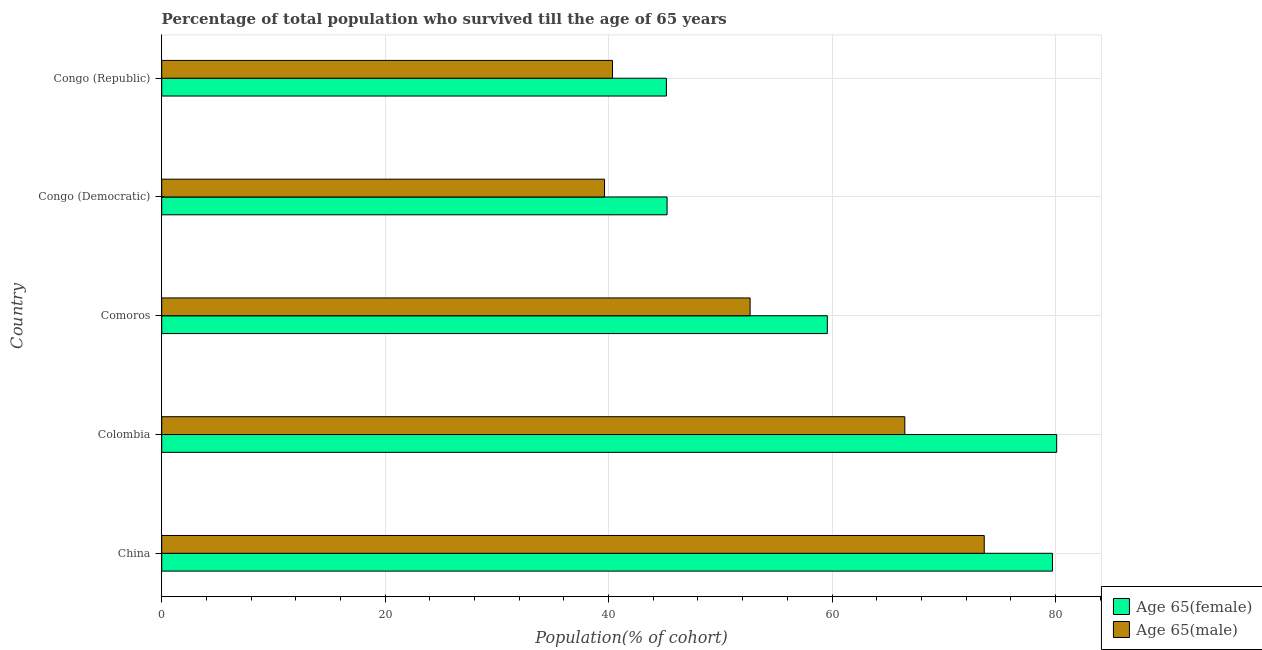How many different coloured bars are there?
Provide a short and direct response. 2. Are the number of bars per tick equal to the number of legend labels?
Give a very brief answer. Yes. How many bars are there on the 5th tick from the top?
Keep it short and to the point. 2. What is the label of the 3rd group of bars from the top?
Give a very brief answer. Comoros. In how many cases, is the number of bars for a given country not equal to the number of legend labels?
Your answer should be very brief. 0. What is the percentage of male population who survived till age of 65 in China?
Offer a terse response. 73.63. Across all countries, what is the maximum percentage of female population who survived till age of 65?
Offer a terse response. 80.11. Across all countries, what is the minimum percentage of male population who survived till age of 65?
Give a very brief answer. 39.64. In which country was the percentage of male population who survived till age of 65 minimum?
Keep it short and to the point. Congo (Democratic). What is the total percentage of male population who survived till age of 65 in the graph?
Offer a terse response. 272.8. What is the difference between the percentage of female population who survived till age of 65 in Colombia and that in Congo (Republic)?
Make the answer very short. 34.94. What is the difference between the percentage of male population who survived till age of 65 in Congo (Democratic) and the percentage of female population who survived till age of 65 in Comoros?
Offer a terse response. -19.94. What is the average percentage of female population who survived till age of 65 per country?
Provide a short and direct response. 61.97. What is the difference between the percentage of female population who survived till age of 65 and percentage of male population who survived till age of 65 in Colombia?
Provide a succinct answer. 13.59. In how many countries, is the percentage of female population who survived till age of 65 greater than 52 %?
Keep it short and to the point. 3. What is the ratio of the percentage of female population who survived till age of 65 in China to that in Congo (Republic)?
Provide a succinct answer. 1.76. What is the difference between the highest and the second highest percentage of male population who survived till age of 65?
Keep it short and to the point. 7.11. What is the difference between the highest and the lowest percentage of male population who survived till age of 65?
Provide a short and direct response. 33.99. What does the 1st bar from the top in Congo (Democratic) represents?
Give a very brief answer. Age 65(male). What does the 2nd bar from the bottom in Congo (Republic) represents?
Offer a very short reply. Age 65(male). How many bars are there?
Keep it short and to the point. 10. Are all the bars in the graph horizontal?
Offer a very short reply. Yes. Does the graph contain any zero values?
Give a very brief answer. No. Does the graph contain grids?
Give a very brief answer. Yes. Where does the legend appear in the graph?
Your answer should be compact. Bottom right. What is the title of the graph?
Give a very brief answer. Percentage of total population who survived till the age of 65 years. What is the label or title of the X-axis?
Make the answer very short. Population(% of cohort). What is the label or title of the Y-axis?
Offer a very short reply. Country. What is the Population(% of cohort) of Age 65(female) in China?
Give a very brief answer. 79.73. What is the Population(% of cohort) of Age 65(male) in China?
Your answer should be compact. 73.63. What is the Population(% of cohort) of Age 65(female) in Colombia?
Provide a short and direct response. 80.11. What is the Population(% of cohort) of Age 65(male) in Colombia?
Offer a terse response. 66.52. What is the Population(% of cohort) of Age 65(female) in Comoros?
Provide a succinct answer. 59.58. What is the Population(% of cohort) in Age 65(male) in Comoros?
Ensure brevity in your answer.  52.67. What is the Population(% of cohort) of Age 65(female) in Congo (Democratic)?
Offer a terse response. 45.24. What is the Population(% of cohort) of Age 65(male) in Congo (Democratic)?
Your response must be concise. 39.64. What is the Population(% of cohort) of Age 65(female) in Congo (Republic)?
Provide a short and direct response. 45.17. What is the Population(% of cohort) in Age 65(male) in Congo (Republic)?
Provide a short and direct response. 40.35. Across all countries, what is the maximum Population(% of cohort) of Age 65(female)?
Your answer should be very brief. 80.11. Across all countries, what is the maximum Population(% of cohort) of Age 65(male)?
Your answer should be very brief. 73.63. Across all countries, what is the minimum Population(% of cohort) in Age 65(female)?
Your response must be concise. 45.17. Across all countries, what is the minimum Population(% of cohort) in Age 65(male)?
Ensure brevity in your answer.  39.64. What is the total Population(% of cohort) of Age 65(female) in the graph?
Make the answer very short. 309.84. What is the total Population(% of cohort) of Age 65(male) in the graph?
Provide a short and direct response. 272.8. What is the difference between the Population(% of cohort) of Age 65(female) in China and that in Colombia?
Offer a terse response. -0.38. What is the difference between the Population(% of cohort) of Age 65(male) in China and that in Colombia?
Keep it short and to the point. 7.11. What is the difference between the Population(% of cohort) of Age 65(female) in China and that in Comoros?
Your answer should be very brief. 20.15. What is the difference between the Population(% of cohort) in Age 65(male) in China and that in Comoros?
Your answer should be compact. 20.96. What is the difference between the Population(% of cohort) in Age 65(female) in China and that in Congo (Democratic)?
Give a very brief answer. 34.5. What is the difference between the Population(% of cohort) in Age 65(male) in China and that in Congo (Democratic)?
Your response must be concise. 33.99. What is the difference between the Population(% of cohort) of Age 65(female) in China and that in Congo (Republic)?
Keep it short and to the point. 34.56. What is the difference between the Population(% of cohort) in Age 65(male) in China and that in Congo (Republic)?
Give a very brief answer. 33.27. What is the difference between the Population(% of cohort) in Age 65(female) in Colombia and that in Comoros?
Keep it short and to the point. 20.53. What is the difference between the Population(% of cohort) in Age 65(male) in Colombia and that in Comoros?
Keep it short and to the point. 13.85. What is the difference between the Population(% of cohort) of Age 65(female) in Colombia and that in Congo (Democratic)?
Your response must be concise. 34.87. What is the difference between the Population(% of cohort) in Age 65(male) in Colombia and that in Congo (Democratic)?
Your response must be concise. 26.88. What is the difference between the Population(% of cohort) in Age 65(female) in Colombia and that in Congo (Republic)?
Give a very brief answer. 34.94. What is the difference between the Population(% of cohort) of Age 65(male) in Colombia and that in Congo (Republic)?
Offer a very short reply. 26.16. What is the difference between the Population(% of cohort) in Age 65(female) in Comoros and that in Congo (Democratic)?
Keep it short and to the point. 14.34. What is the difference between the Population(% of cohort) in Age 65(male) in Comoros and that in Congo (Democratic)?
Give a very brief answer. 13.03. What is the difference between the Population(% of cohort) of Age 65(female) in Comoros and that in Congo (Republic)?
Provide a succinct answer. 14.41. What is the difference between the Population(% of cohort) of Age 65(male) in Comoros and that in Congo (Republic)?
Your answer should be compact. 12.32. What is the difference between the Population(% of cohort) of Age 65(female) in Congo (Democratic) and that in Congo (Republic)?
Ensure brevity in your answer.  0.06. What is the difference between the Population(% of cohort) of Age 65(male) in Congo (Democratic) and that in Congo (Republic)?
Provide a succinct answer. -0.71. What is the difference between the Population(% of cohort) in Age 65(female) in China and the Population(% of cohort) in Age 65(male) in Colombia?
Make the answer very short. 13.22. What is the difference between the Population(% of cohort) in Age 65(female) in China and the Population(% of cohort) in Age 65(male) in Comoros?
Provide a short and direct response. 27.06. What is the difference between the Population(% of cohort) in Age 65(female) in China and the Population(% of cohort) in Age 65(male) in Congo (Democratic)?
Your answer should be very brief. 40.1. What is the difference between the Population(% of cohort) of Age 65(female) in China and the Population(% of cohort) of Age 65(male) in Congo (Republic)?
Offer a terse response. 39.38. What is the difference between the Population(% of cohort) in Age 65(female) in Colombia and the Population(% of cohort) in Age 65(male) in Comoros?
Provide a short and direct response. 27.44. What is the difference between the Population(% of cohort) of Age 65(female) in Colombia and the Population(% of cohort) of Age 65(male) in Congo (Democratic)?
Keep it short and to the point. 40.47. What is the difference between the Population(% of cohort) of Age 65(female) in Colombia and the Population(% of cohort) of Age 65(male) in Congo (Republic)?
Make the answer very short. 39.76. What is the difference between the Population(% of cohort) of Age 65(female) in Comoros and the Population(% of cohort) of Age 65(male) in Congo (Democratic)?
Your answer should be compact. 19.94. What is the difference between the Population(% of cohort) in Age 65(female) in Comoros and the Population(% of cohort) in Age 65(male) in Congo (Republic)?
Provide a succinct answer. 19.23. What is the difference between the Population(% of cohort) of Age 65(female) in Congo (Democratic) and the Population(% of cohort) of Age 65(male) in Congo (Republic)?
Offer a very short reply. 4.89. What is the average Population(% of cohort) in Age 65(female) per country?
Offer a terse response. 61.97. What is the average Population(% of cohort) in Age 65(male) per country?
Keep it short and to the point. 54.56. What is the difference between the Population(% of cohort) of Age 65(female) and Population(% of cohort) of Age 65(male) in China?
Your response must be concise. 6.11. What is the difference between the Population(% of cohort) in Age 65(female) and Population(% of cohort) in Age 65(male) in Colombia?
Give a very brief answer. 13.59. What is the difference between the Population(% of cohort) of Age 65(female) and Population(% of cohort) of Age 65(male) in Comoros?
Your answer should be very brief. 6.91. What is the difference between the Population(% of cohort) of Age 65(female) and Population(% of cohort) of Age 65(male) in Congo (Democratic)?
Give a very brief answer. 5.6. What is the difference between the Population(% of cohort) of Age 65(female) and Population(% of cohort) of Age 65(male) in Congo (Republic)?
Give a very brief answer. 4.82. What is the ratio of the Population(% of cohort) of Age 65(female) in China to that in Colombia?
Your answer should be compact. 1. What is the ratio of the Population(% of cohort) in Age 65(male) in China to that in Colombia?
Your response must be concise. 1.11. What is the ratio of the Population(% of cohort) of Age 65(female) in China to that in Comoros?
Your answer should be compact. 1.34. What is the ratio of the Population(% of cohort) of Age 65(male) in China to that in Comoros?
Your response must be concise. 1.4. What is the ratio of the Population(% of cohort) of Age 65(female) in China to that in Congo (Democratic)?
Offer a very short reply. 1.76. What is the ratio of the Population(% of cohort) of Age 65(male) in China to that in Congo (Democratic)?
Offer a very short reply. 1.86. What is the ratio of the Population(% of cohort) of Age 65(female) in China to that in Congo (Republic)?
Provide a short and direct response. 1.76. What is the ratio of the Population(% of cohort) of Age 65(male) in China to that in Congo (Republic)?
Your response must be concise. 1.82. What is the ratio of the Population(% of cohort) of Age 65(female) in Colombia to that in Comoros?
Provide a short and direct response. 1.34. What is the ratio of the Population(% of cohort) of Age 65(male) in Colombia to that in Comoros?
Offer a terse response. 1.26. What is the ratio of the Population(% of cohort) in Age 65(female) in Colombia to that in Congo (Democratic)?
Offer a terse response. 1.77. What is the ratio of the Population(% of cohort) in Age 65(male) in Colombia to that in Congo (Democratic)?
Give a very brief answer. 1.68. What is the ratio of the Population(% of cohort) in Age 65(female) in Colombia to that in Congo (Republic)?
Ensure brevity in your answer.  1.77. What is the ratio of the Population(% of cohort) in Age 65(male) in Colombia to that in Congo (Republic)?
Make the answer very short. 1.65. What is the ratio of the Population(% of cohort) of Age 65(female) in Comoros to that in Congo (Democratic)?
Offer a terse response. 1.32. What is the ratio of the Population(% of cohort) in Age 65(male) in Comoros to that in Congo (Democratic)?
Provide a succinct answer. 1.33. What is the ratio of the Population(% of cohort) of Age 65(female) in Comoros to that in Congo (Republic)?
Your response must be concise. 1.32. What is the ratio of the Population(% of cohort) of Age 65(male) in Comoros to that in Congo (Republic)?
Provide a short and direct response. 1.31. What is the ratio of the Population(% of cohort) in Age 65(female) in Congo (Democratic) to that in Congo (Republic)?
Keep it short and to the point. 1. What is the ratio of the Population(% of cohort) in Age 65(male) in Congo (Democratic) to that in Congo (Republic)?
Offer a very short reply. 0.98. What is the difference between the highest and the second highest Population(% of cohort) in Age 65(female)?
Provide a short and direct response. 0.38. What is the difference between the highest and the second highest Population(% of cohort) in Age 65(male)?
Your answer should be very brief. 7.11. What is the difference between the highest and the lowest Population(% of cohort) in Age 65(female)?
Provide a short and direct response. 34.94. What is the difference between the highest and the lowest Population(% of cohort) in Age 65(male)?
Provide a short and direct response. 33.99. 